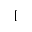Convert formula to latex. <formula><loc_0><loc_0><loc_500><loc_500>[</formula> 